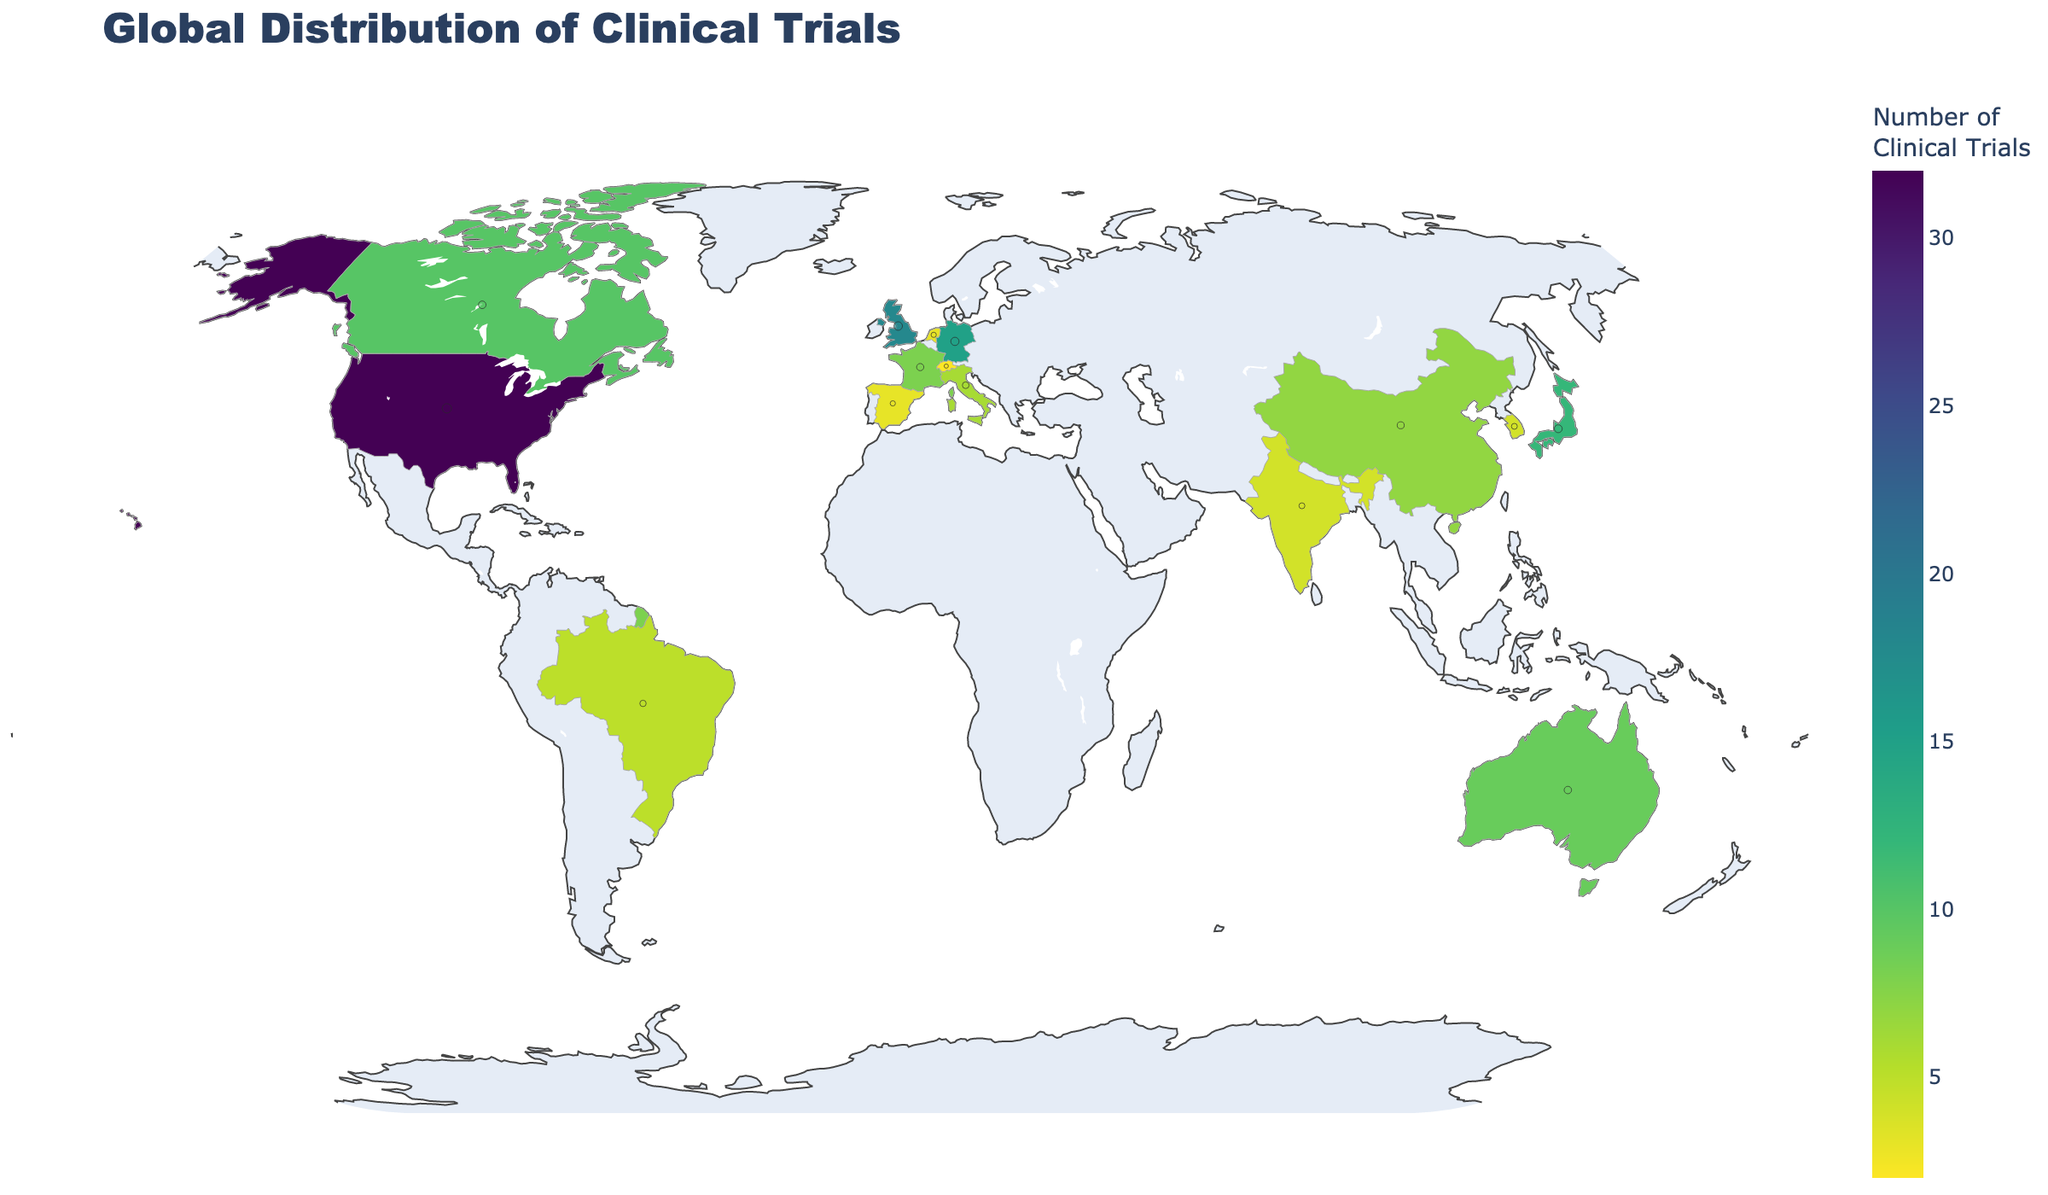How many clinical trials are being conducted in the United States? The map shows the global distribution of clinical trials. By looking at the United States, we see that the number of clinical trials is 32.
Answer: 32 What is the primary research center in Canada? The map provides both the number of clinical trials and the primary research center for each country. For Canada, the primary research center is Toronto General Hospital.
Answer: Toronto General Hospital Which country has the second highest number of clinical trials? From the map, we see that the United States has the highest with 32 trials. The United Kingdom follows with 18 clinical trials, making it the second highest.
Answer: United Kingdom What is the sum of clinical trials conducted in Germany and Japan? According to the map, Germany has 15 clinical trials and Japan has 12. The sum of these trials is 15 + 12, which equals 27.
Answer: 27 Which country has fewer clinical trials, China or Italy? From the map, China has 7 clinical trials, and Italy has 6 clinical trials. Italy has fewer clinical trials.
Answer: Italy What is the color scale used in the map? The map employs a Viridis color scale to represent the number of clinical trials globally.
Answer: Viridis Of the countries listed, which one is conducting the lowest number of clinical trials, and how many are there? The map shows that Switzerland is conducting the lowest number of clinical trials with 2 trials.
Answer: Switzerland, 2 What research center is primarily involved in clinical trials in Brazil? The map indicates that the primary research center in Brazil is Hospital das Clínicas da Faculdade de Medicina da USP.
Answer: Hospital das Clínicas da Faculdade de Medicina da USP Compare the number of clinical trials between Australia and France. Which one has more, and by how many? The map shows that Australia has 9 clinical trials, while France has 8. Therefore, Australia has 1 more clinical trial than France.
Answer: Australia, 1 How many countries on the map have 4 or fewer clinical trials? The countries with 4 or fewer clinical trials are India, South Korea, Spain, Netherlands, and Switzerland. There are 5 such countries.
Answer: 5 